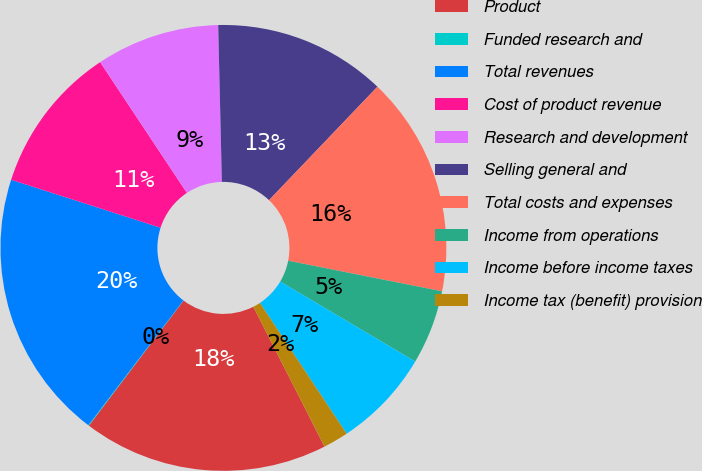<chart> <loc_0><loc_0><loc_500><loc_500><pie_chart><fcel>Product<fcel>Funded research and<fcel>Total revenues<fcel>Cost of product revenue<fcel>Research and development<fcel>Selling general and<fcel>Total costs and expenses<fcel>Income from operations<fcel>Income before income taxes<fcel>Income tax (benefit) provision<nl><fcel>17.8%<fcel>0.05%<fcel>19.58%<fcel>10.73%<fcel>8.95%<fcel>12.51%<fcel>15.98%<fcel>5.39%<fcel>7.17%<fcel>1.83%<nl></chart> 